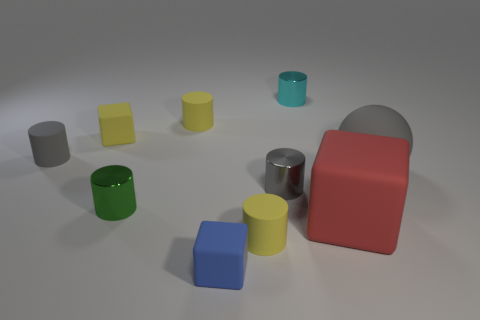Are there any blue rubber cylinders? No, there are no blue rubber cylinders in the image. However, there are several cylinders of various colors, including a green and a yellow cylinder, as well as objects of other shapes like cubes and a rectangular prism. 